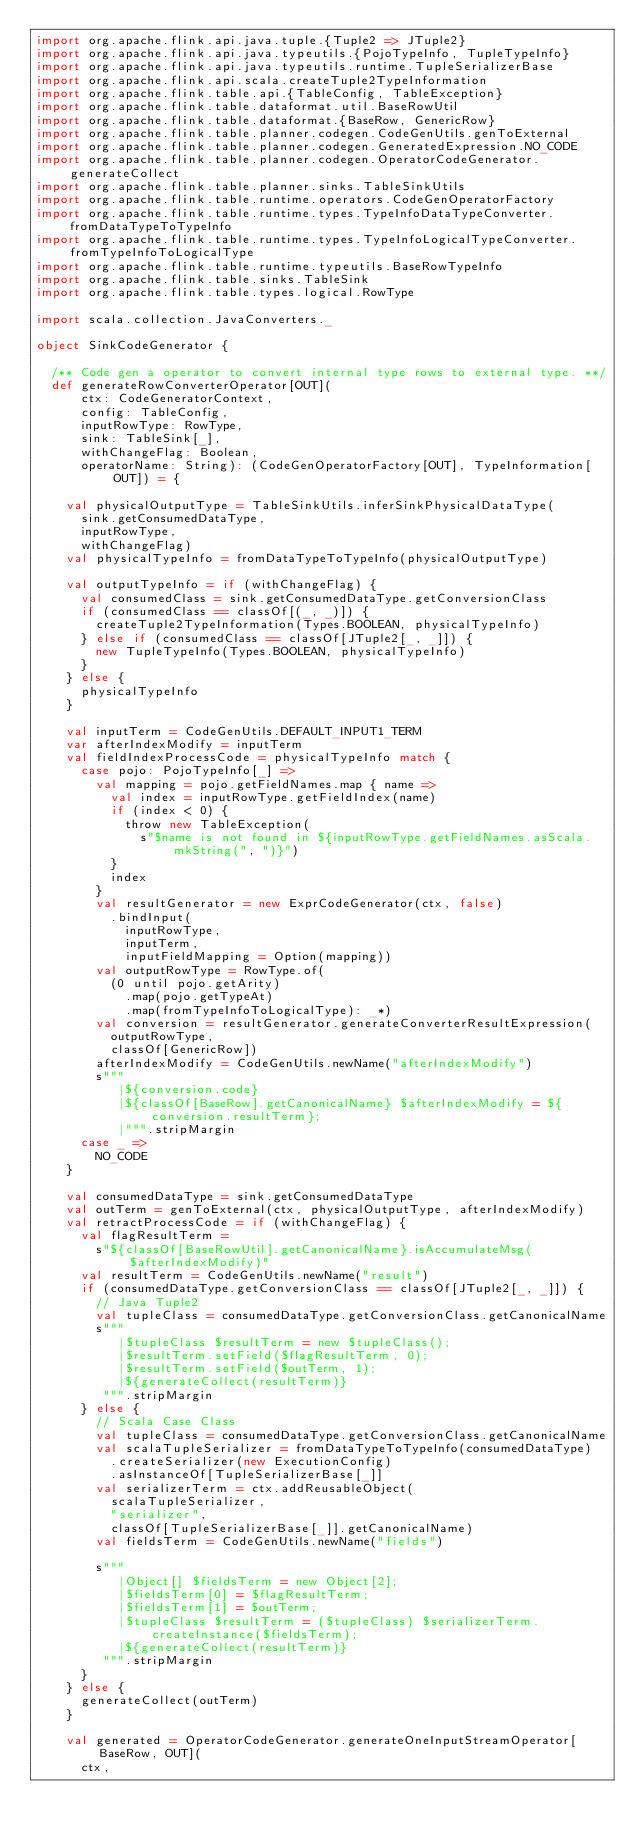Convert code to text. <code><loc_0><loc_0><loc_500><loc_500><_Scala_>import org.apache.flink.api.java.tuple.{Tuple2 => JTuple2}
import org.apache.flink.api.java.typeutils.{PojoTypeInfo, TupleTypeInfo}
import org.apache.flink.api.java.typeutils.runtime.TupleSerializerBase
import org.apache.flink.api.scala.createTuple2TypeInformation
import org.apache.flink.table.api.{TableConfig, TableException}
import org.apache.flink.table.dataformat.util.BaseRowUtil
import org.apache.flink.table.dataformat.{BaseRow, GenericRow}
import org.apache.flink.table.planner.codegen.CodeGenUtils.genToExternal
import org.apache.flink.table.planner.codegen.GeneratedExpression.NO_CODE
import org.apache.flink.table.planner.codegen.OperatorCodeGenerator.generateCollect
import org.apache.flink.table.planner.sinks.TableSinkUtils
import org.apache.flink.table.runtime.operators.CodeGenOperatorFactory
import org.apache.flink.table.runtime.types.TypeInfoDataTypeConverter.fromDataTypeToTypeInfo
import org.apache.flink.table.runtime.types.TypeInfoLogicalTypeConverter.fromTypeInfoToLogicalType
import org.apache.flink.table.runtime.typeutils.BaseRowTypeInfo
import org.apache.flink.table.sinks.TableSink
import org.apache.flink.table.types.logical.RowType

import scala.collection.JavaConverters._

object SinkCodeGenerator {

  /** Code gen a operator to convert internal type rows to external type. **/
  def generateRowConverterOperator[OUT](
      ctx: CodeGeneratorContext,
      config: TableConfig,
      inputRowType: RowType,
      sink: TableSink[_],
      withChangeFlag: Boolean,
      operatorName: String): (CodeGenOperatorFactory[OUT], TypeInformation[OUT]) = {

    val physicalOutputType = TableSinkUtils.inferSinkPhysicalDataType(
      sink.getConsumedDataType,
      inputRowType,
      withChangeFlag)
    val physicalTypeInfo = fromDataTypeToTypeInfo(physicalOutputType)

    val outputTypeInfo = if (withChangeFlag) {
      val consumedClass = sink.getConsumedDataType.getConversionClass
      if (consumedClass == classOf[(_, _)]) {
        createTuple2TypeInformation(Types.BOOLEAN, physicalTypeInfo)
      } else if (consumedClass == classOf[JTuple2[_, _]]) {
        new TupleTypeInfo(Types.BOOLEAN, physicalTypeInfo)
      }
    } else {
      physicalTypeInfo
    }

    val inputTerm = CodeGenUtils.DEFAULT_INPUT1_TERM
    var afterIndexModify = inputTerm
    val fieldIndexProcessCode = physicalTypeInfo match {
      case pojo: PojoTypeInfo[_] =>
        val mapping = pojo.getFieldNames.map { name =>
          val index = inputRowType.getFieldIndex(name)
          if (index < 0) {
            throw new TableException(
              s"$name is not found in ${inputRowType.getFieldNames.asScala.mkString(", ")}")
          }
          index
        }
        val resultGenerator = new ExprCodeGenerator(ctx, false)
          .bindInput(
            inputRowType,
            inputTerm,
            inputFieldMapping = Option(mapping))
        val outputRowType = RowType.of(
          (0 until pojo.getArity)
            .map(pojo.getTypeAt)
            .map(fromTypeInfoToLogicalType): _*)
        val conversion = resultGenerator.generateConverterResultExpression(
          outputRowType,
          classOf[GenericRow])
        afterIndexModify = CodeGenUtils.newName("afterIndexModify")
        s"""
           |${conversion.code}
           |${classOf[BaseRow].getCanonicalName} $afterIndexModify = ${conversion.resultTerm};
           |""".stripMargin
      case _ =>
        NO_CODE
    }

    val consumedDataType = sink.getConsumedDataType
    val outTerm = genToExternal(ctx, physicalOutputType, afterIndexModify)
    val retractProcessCode = if (withChangeFlag) {
      val flagResultTerm =
        s"${classOf[BaseRowUtil].getCanonicalName}.isAccumulateMsg($afterIndexModify)"
      val resultTerm = CodeGenUtils.newName("result")
      if (consumedDataType.getConversionClass == classOf[JTuple2[_, _]]) {
        // Java Tuple2
        val tupleClass = consumedDataType.getConversionClass.getCanonicalName
        s"""
           |$tupleClass $resultTerm = new $tupleClass();
           |$resultTerm.setField($flagResultTerm, 0);
           |$resultTerm.setField($outTerm, 1);
           |${generateCollect(resultTerm)}
         """.stripMargin
      } else {
        // Scala Case Class
        val tupleClass = consumedDataType.getConversionClass.getCanonicalName
        val scalaTupleSerializer = fromDataTypeToTypeInfo(consumedDataType)
          .createSerializer(new ExecutionConfig)
          .asInstanceOf[TupleSerializerBase[_]]
        val serializerTerm = ctx.addReusableObject(
          scalaTupleSerializer,
          "serializer",
          classOf[TupleSerializerBase[_]].getCanonicalName)
        val fieldsTerm = CodeGenUtils.newName("fields")

        s"""
           |Object[] $fieldsTerm = new Object[2];
           |$fieldsTerm[0] = $flagResultTerm;
           |$fieldsTerm[1] = $outTerm;
           |$tupleClass $resultTerm = ($tupleClass) $serializerTerm.createInstance($fieldsTerm);
           |${generateCollect(resultTerm)}
         """.stripMargin
      }
    } else {
      generateCollect(outTerm)
    }

    val generated = OperatorCodeGenerator.generateOneInputStreamOperator[BaseRow, OUT](
      ctx,</code> 